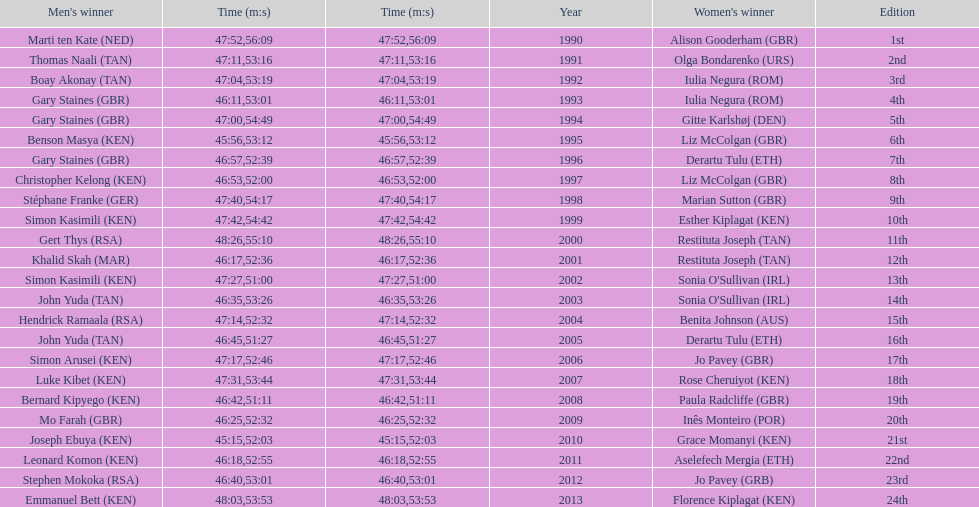Who has the fastest recorded finish for the men's bupa great south run, between 1990 and 2013? Joseph Ebuya (KEN). 